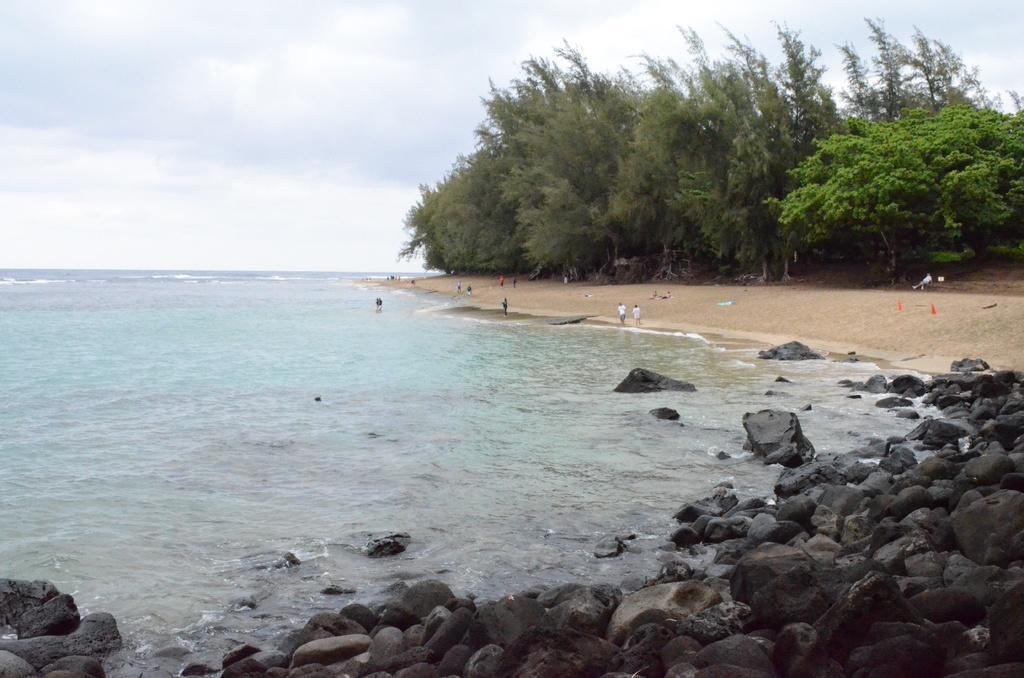Please provide a concise description of this image. In the foreground we can see the stones on the side of a beach. Here we can see the ocean. Here we can see a few people on the side of a beach. Here we can see the trees. This is a sky with clouds. 